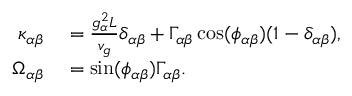<formula> <loc_0><loc_0><loc_500><loc_500>\begin{array} { r l } { \kappa _ { \alpha \beta } } & = \frac { g _ { \alpha } ^ { 2 } L } { v _ { g } } \delta _ { \alpha \beta } + \Gamma _ { \alpha \beta } \cos ( \phi _ { \alpha \beta } ) ( 1 - \delta _ { \alpha \beta } ) , } \\ { \Omega _ { \alpha \beta } } & = \sin ( \phi _ { \alpha \beta } ) \Gamma _ { \alpha \beta } . } \end{array}</formula> 